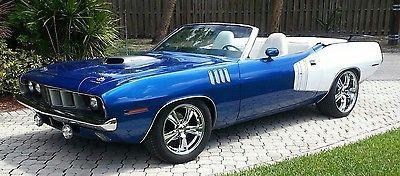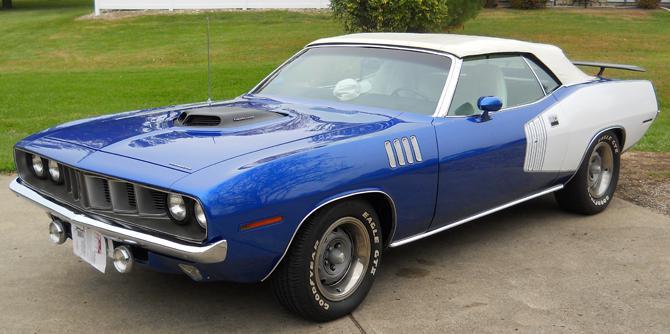The first image is the image on the left, the second image is the image on the right. Given the left and right images, does the statement "The car in the image on the right is parked near the green grass." hold true? Answer yes or no. Yes. The first image is the image on the left, the second image is the image on the right. Evaluate the accuracy of this statement regarding the images: "There are two cars that are the same color, but one has the top down while the other has its top up". Is it true? Answer yes or no. Yes. 